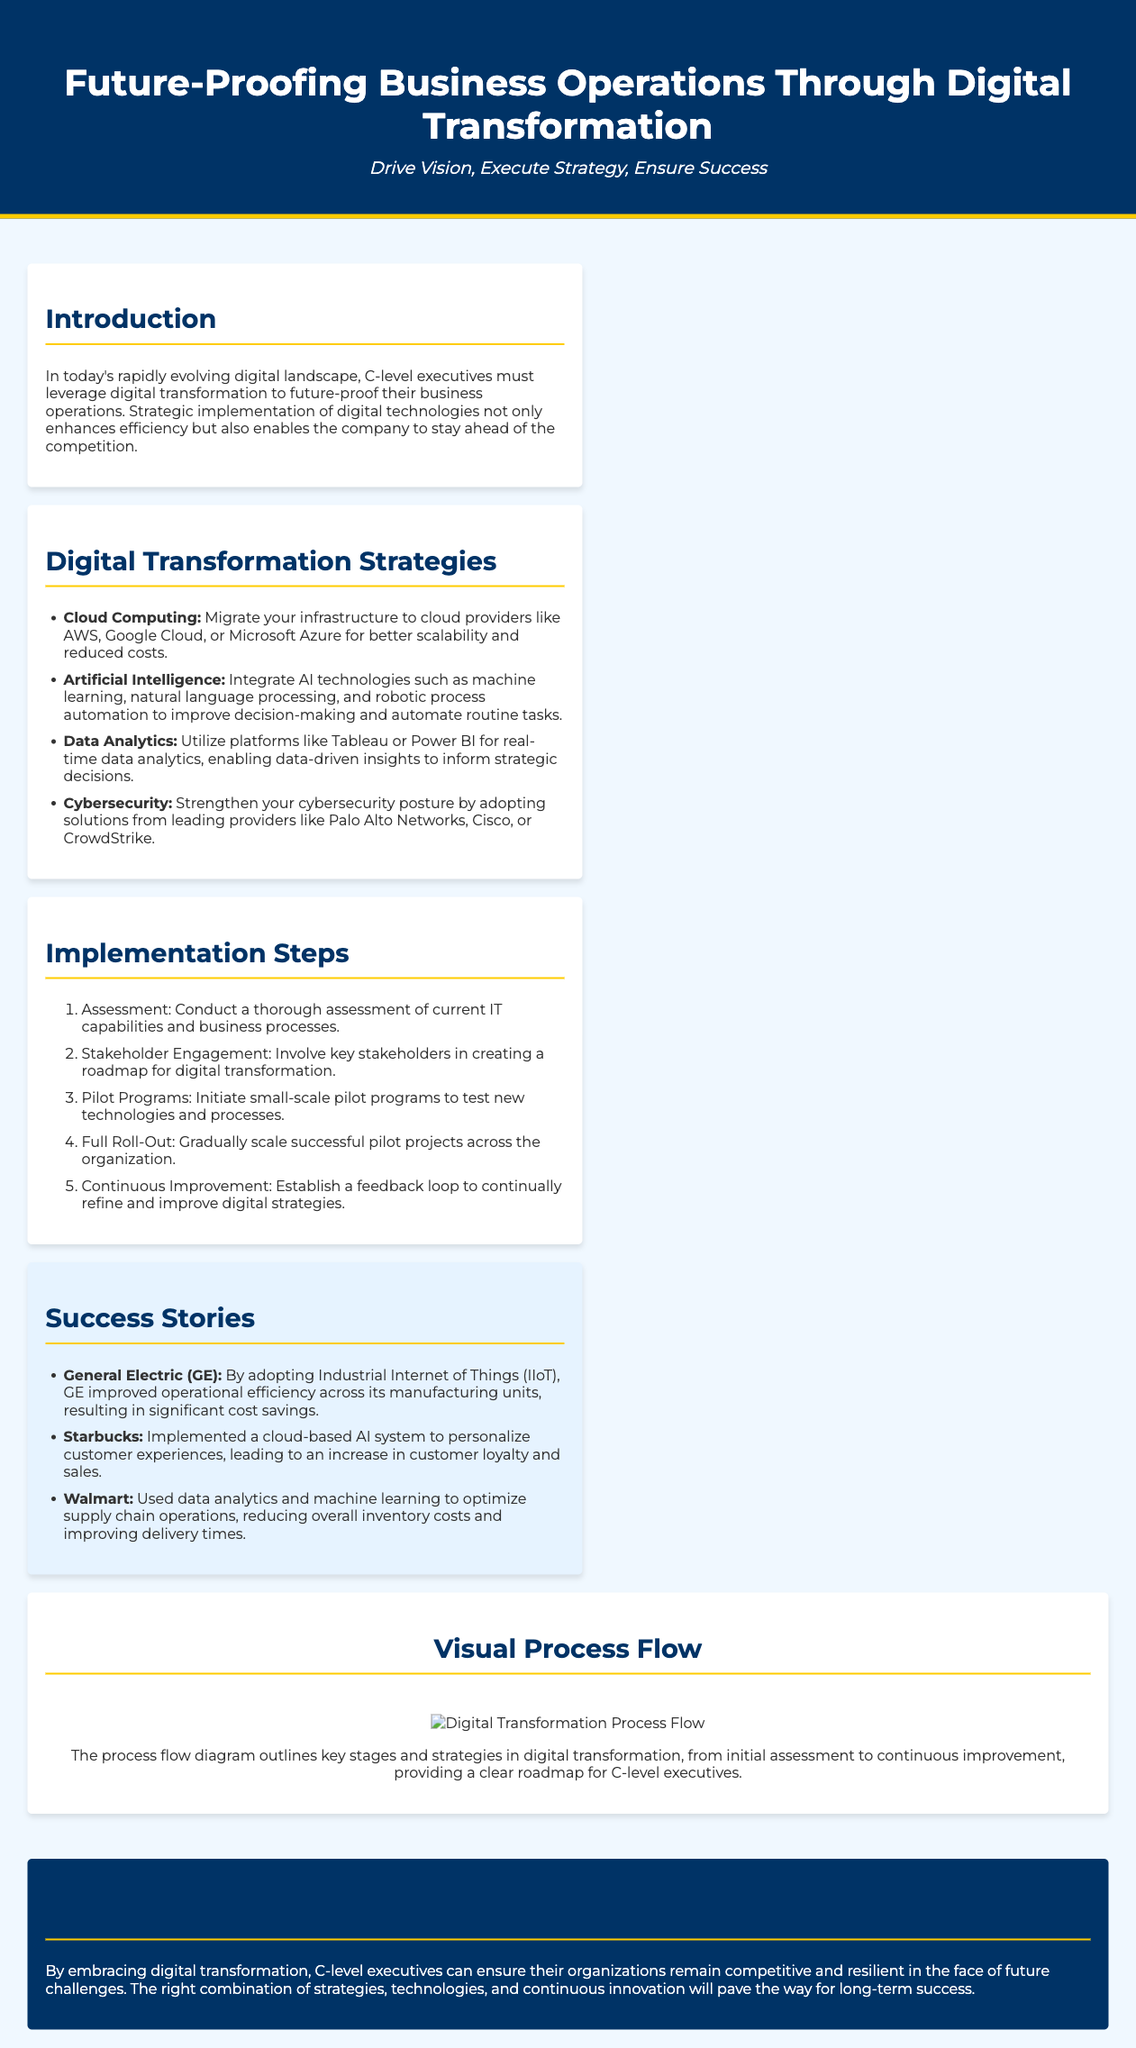What is the title of the document? The title is prominently displayed in the header of the document.
Answer: Future-Proofing Business Operations Through Digital Transformation Who are the primary stakeholders in the digital transformation process? Stakeholder Engagement section indicates the involvement of key stakeholders is crucial.
Answer: Key stakeholders What technology did Starbucks implement for customer experiences? The Success Stories section highlights the cloud-based AI system adopted by Starbucks.
Answer: Cloud-based AI system What is the first step in the implementation process? The Implementation Steps section lists the steps sequentially, starting with the assessment.
Answer: Assessment Which company improved operational efficiency through IIoT? The Success Stories section mentions GE's adoption of IIoT for efficiency improvements.
Answer: General Electric What major benefit does digital transformation provide according to the conclusion? The conclusion emphasizes the competitive edge and resilience gained through digital transformation.
Answer: Competitive and resilient How many digital transformation strategies are listed in the document? The Digital Transformation Strategies section enumerates a total of four strategies.
Answer: Four What type of process flow is visually represented in the document? The Visual Process Flow section describes a clear diagram outlining key stages of digital transformation.
Answer: Digital transformation process flow What color scheme is used for the header? The header features a specific color scheme of dark blue background and white text.
Answer: Dark blue and white 